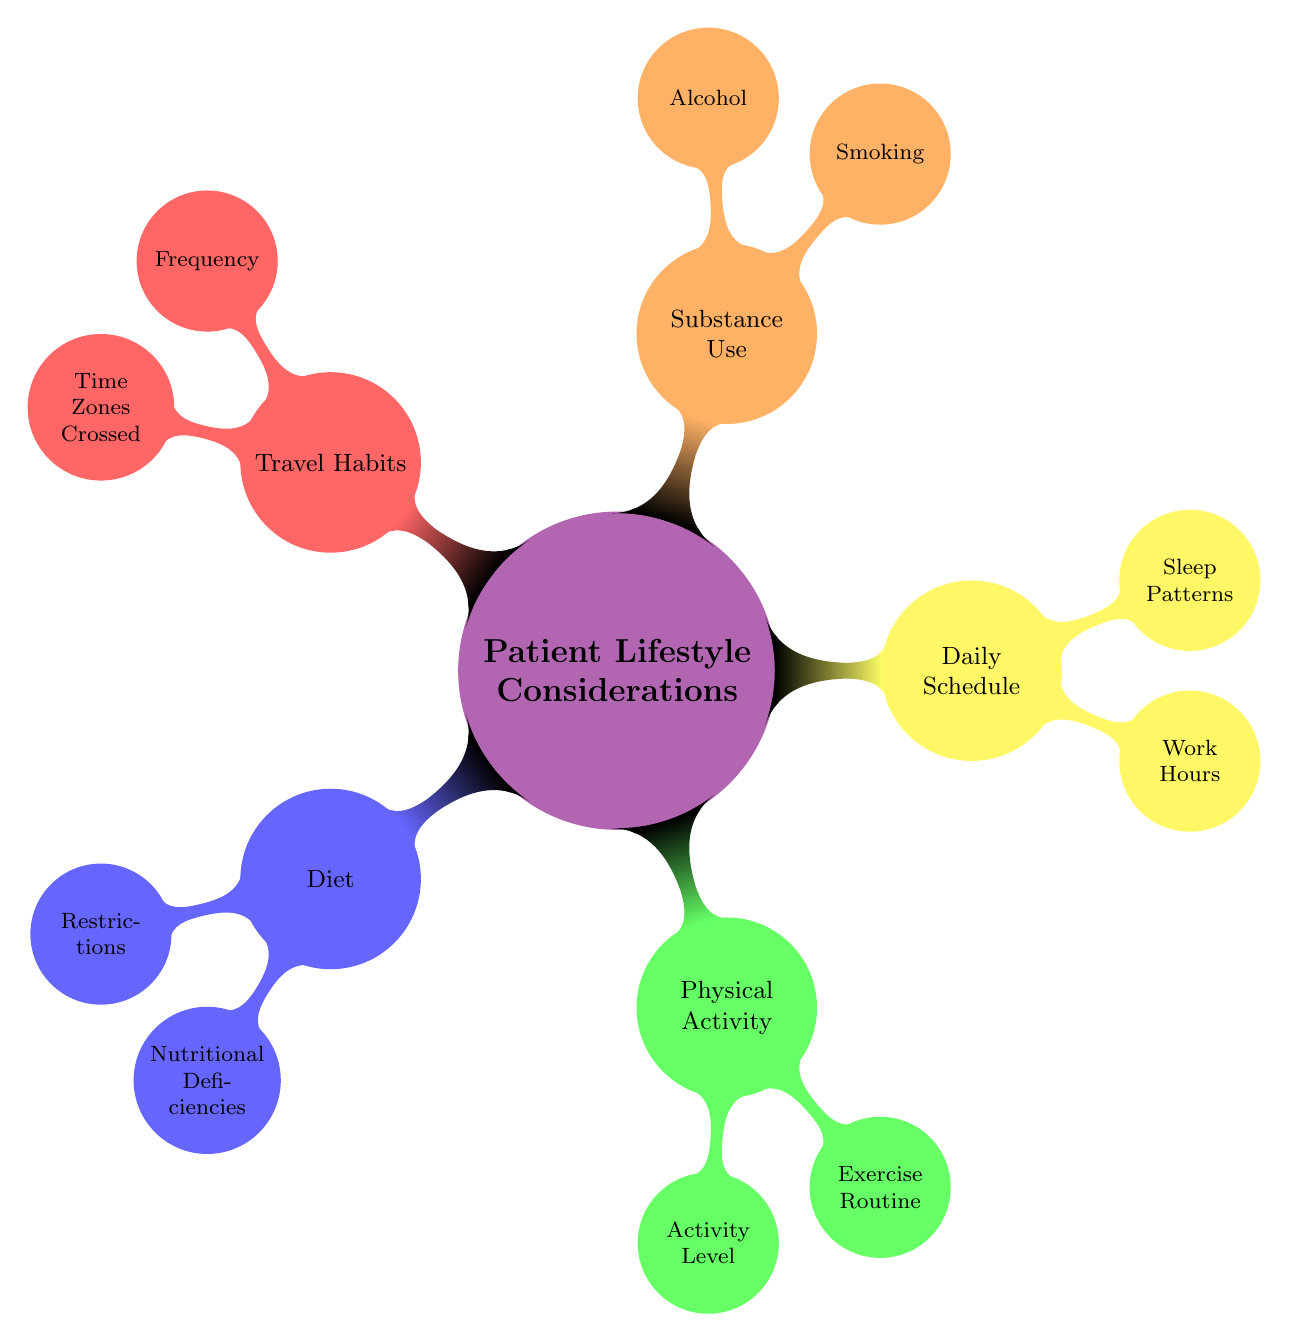What are three dietary restrictions mentioned? The diagram lists three dietary restrictions under the "Diet" node: Gluten-Free, Vegan, and Diabetic.
Answer: Gluten-Free, Vegan, Diabetic How many nodes are under "Substance Use"? There are two nodes branching out from "Substance Use": "Smoking" and "Alcohol," which means there are a total of 2 nodes.
Answer: 2 What are the three activity levels indicated? The "Physical Activity" section includes three activity levels: Sedentary, Moderately Active, and Vigorously Active.
Answer: Sedentary, Moderately Active, Vigorously Active Which factor relates to daily work hours? The diagram states that "Work Hours" is a part of the "Daily Schedule" category.
Answer: Work Hours What is the relationship of "Smoking" to "Substance Use"? "Smoking" is a sub-node that directly branches from the "Substance Use" node, indicating that it is a component or consideration within that category.
Answer: Smoking is a sub-node of Substance Use What are the two types of exercise routines listed? Under "Physical Activity," the diagram mentions two types of exercise routines: Cardio and Strength Training, along with Yoga.
Answer: Cardio, Strength Training, Yoga How do travel habits vary based on frequency? The diagram categorizes "Travel Habits" into three levels of frequency: Rarely Travels, Frequent Business Travel, and Frequent Leisure Travel, showing how travel behaviors differ.
Answer: Rarely Travels, Frequent Business Travel, Frequent Leisure Travel How many sleep patterns are described? The "Daily Schedule" section mentions three sleep patterns: Insomnia, Normal Sleep, and Shift Work Sleep Disorder, thereby indicating three patterns in total.
Answer: 3 Which nutritional deficiency is highlighted in the diet? The diagram specifically lists three nutritional deficiencies related to diet; one of them is Iron, alongside Vitamin D and Calcium.
Answer: Iron 